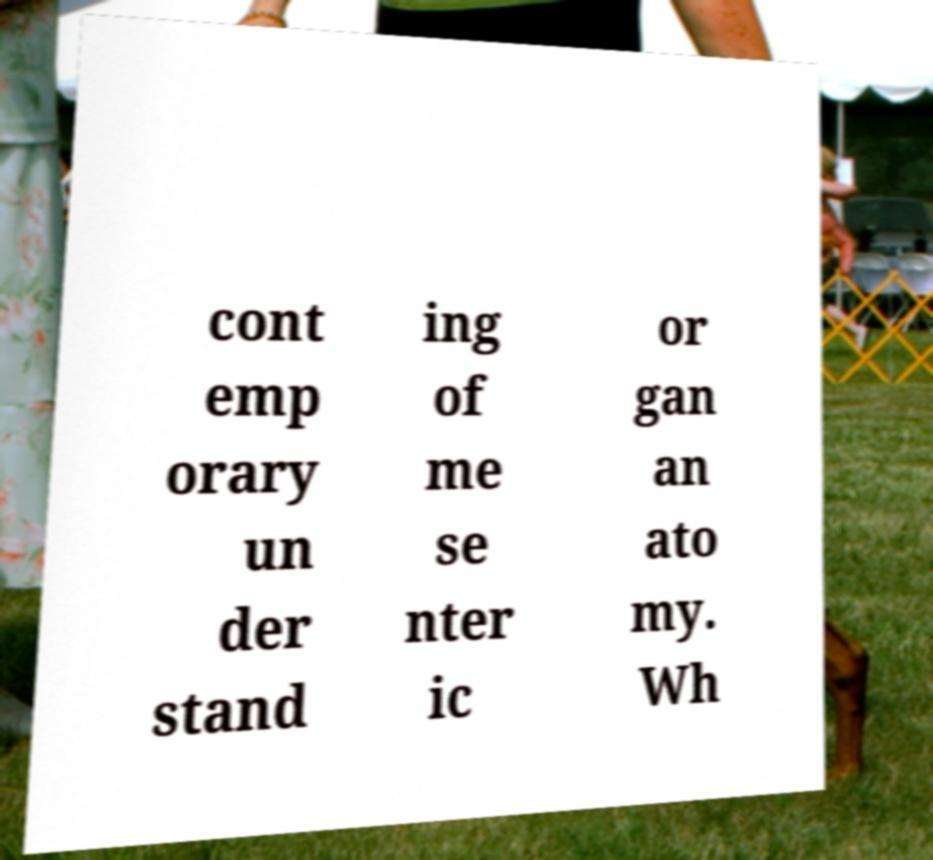Please read and relay the text visible in this image. What does it say? cont emp orary un der stand ing of me se nter ic or gan an ato my. Wh 